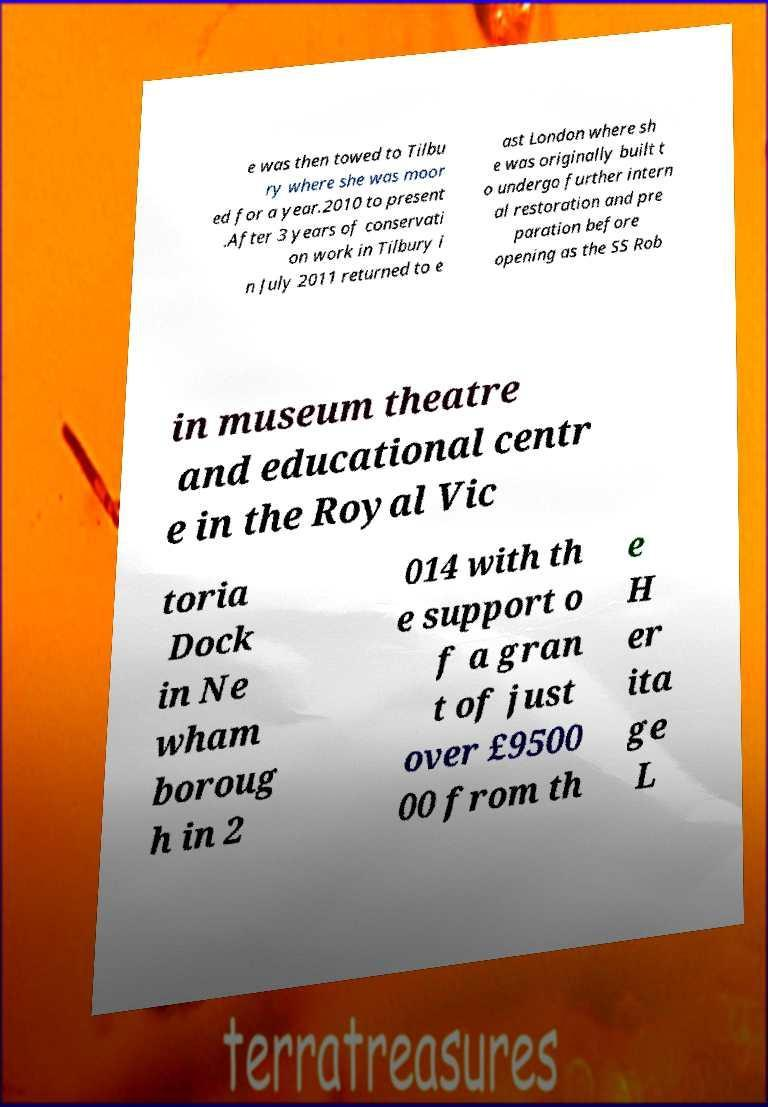Could you extract and type out the text from this image? e was then towed to Tilbu ry where she was moor ed for a year.2010 to present .After 3 years of conservati on work in Tilbury i n July 2011 returned to e ast London where sh e was originally built t o undergo further intern al restoration and pre paration before opening as the SS Rob in museum theatre and educational centr e in the Royal Vic toria Dock in Ne wham boroug h in 2 014 with th e support o f a gran t of just over £9500 00 from th e H er ita ge L 